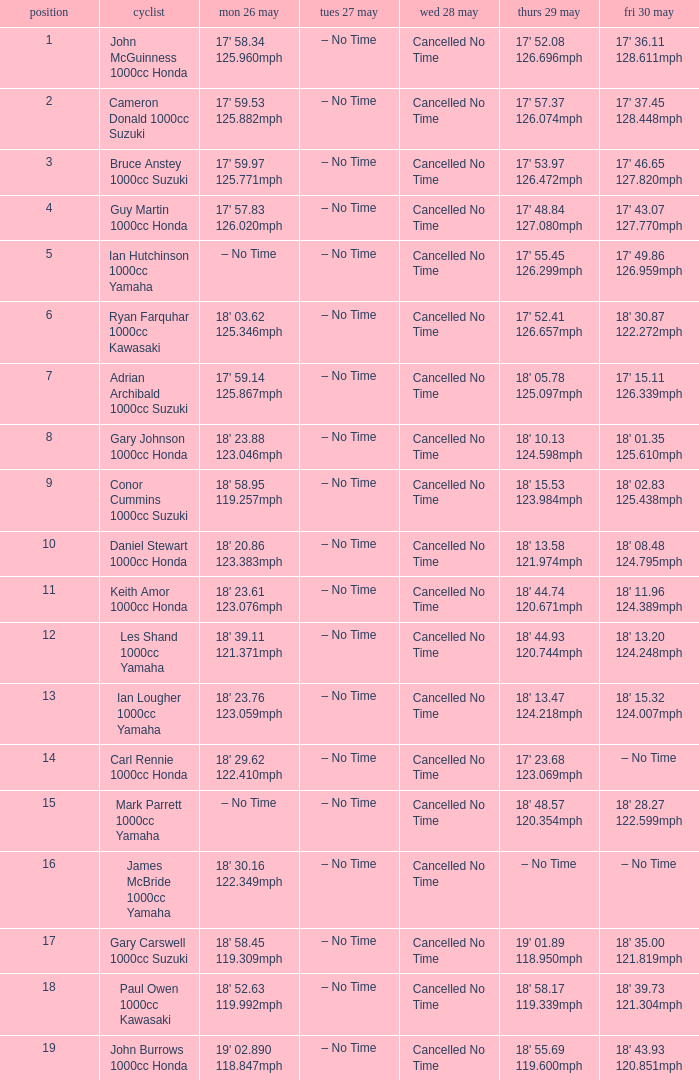Parse the full table. {'header': ['position', 'cyclist', 'mon 26 may', 'tues 27 may', 'wed 28 may', 'thurs 29 may', 'fri 30 may'], 'rows': [['1', 'John McGuinness 1000cc Honda', "17' 58.34 125.960mph", '– No Time', 'Cancelled No Time', "17' 52.08 126.696mph", "17' 36.11 128.611mph"], ['2', 'Cameron Donald 1000cc Suzuki', "17' 59.53 125.882mph", '– No Time', 'Cancelled No Time', "17' 57.37 126.074mph", "17' 37.45 128.448mph"], ['3', 'Bruce Anstey 1000cc Suzuki', "17' 59.97 125.771mph", '– No Time', 'Cancelled No Time', "17' 53.97 126.472mph", "17' 46.65 127.820mph"], ['4', 'Guy Martin 1000cc Honda', "17' 57.83 126.020mph", '– No Time', 'Cancelled No Time', "17' 48.84 127.080mph", "17' 43.07 127.770mph"], ['5', 'Ian Hutchinson 1000cc Yamaha', '– No Time', '– No Time', 'Cancelled No Time', "17' 55.45 126.299mph", "17' 49.86 126.959mph"], ['6', 'Ryan Farquhar 1000cc Kawasaki', "18' 03.62 125.346mph", '– No Time', 'Cancelled No Time', "17' 52.41 126.657mph", "18' 30.87 122.272mph"], ['7', 'Adrian Archibald 1000cc Suzuki', "17' 59.14 125.867mph", '– No Time', 'Cancelled No Time', "18' 05.78 125.097mph", "17' 15.11 126.339mph"], ['8', 'Gary Johnson 1000cc Honda', "18' 23.88 123.046mph", '– No Time', 'Cancelled No Time', "18' 10.13 124.598mph", "18' 01.35 125.610mph"], ['9', 'Conor Cummins 1000cc Suzuki', "18' 58.95 119.257mph", '– No Time', 'Cancelled No Time', "18' 15.53 123.984mph", "18' 02.83 125.438mph"], ['10', 'Daniel Stewart 1000cc Honda', "18' 20.86 123.383mph", '– No Time', 'Cancelled No Time', "18' 13.58 121.974mph", "18' 08.48 124.795mph"], ['11', 'Keith Amor 1000cc Honda', "18' 23.61 123.076mph", '– No Time', 'Cancelled No Time', "18' 44.74 120.671mph", "18' 11.96 124.389mph"], ['12', 'Les Shand 1000cc Yamaha', "18' 39.11 121.371mph", '– No Time', 'Cancelled No Time', "18' 44.93 120.744mph", "18' 13.20 124.248mph"], ['13', 'Ian Lougher 1000cc Yamaha', "18' 23.76 123.059mph", '– No Time', 'Cancelled No Time', "18' 13.47 124.218mph", "18' 15.32 124.007mph"], ['14', 'Carl Rennie 1000cc Honda', "18' 29.62 122.410mph", '– No Time', 'Cancelled No Time', "17' 23.68 123.069mph", '– No Time'], ['15', 'Mark Parrett 1000cc Yamaha', '– No Time', '– No Time', 'Cancelled No Time', "18' 48.57 120.354mph", "18' 28.27 122.599mph"], ['16', 'James McBride 1000cc Yamaha', "18' 30.16 122.349mph", '– No Time', 'Cancelled No Time', '– No Time', '– No Time'], ['17', 'Gary Carswell 1000cc Suzuki', "18' 58.45 119.309mph", '– No Time', 'Cancelled No Time', "19' 01.89 118.950mph", "18' 35.00 121.819mph"], ['18', 'Paul Owen 1000cc Kawasaki', "18' 52.63 119.992mph", '– No Time', 'Cancelled No Time', "18' 58.17 119.339mph", "18' 39.73 121.304mph"], ['19', 'John Burrows 1000cc Honda', "19' 02.890 118.847mph", '– No Time', 'Cancelled No Time', "18' 55.69 119.600mph", "18' 43.93 120.851mph"]]} What tims is wed may 28 and mon may 26 is 17' 58.34 125.960mph? Cancelled No Time. 